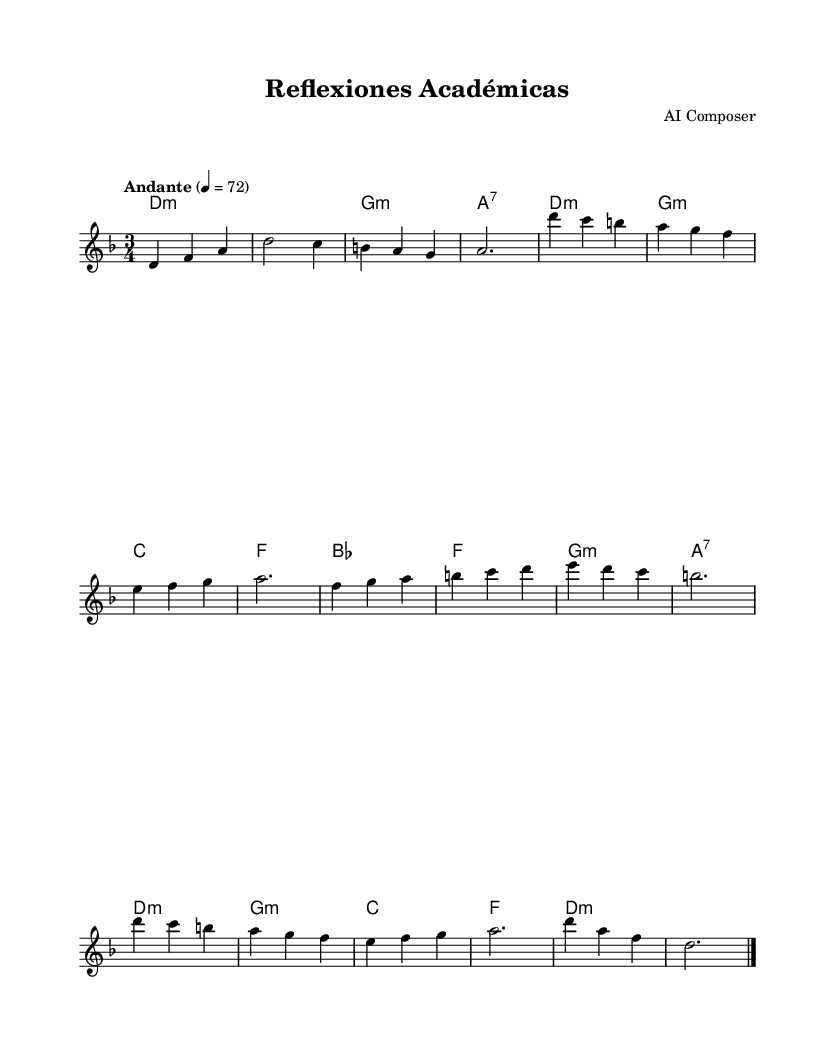What is the key signature of this music? The key signature is determined by the first section of the music, where there are no sharps or flats indicated. This means the key of D minor, which has one flat (B-flat), is set in this piece.
Answer: D minor What is the time signature of this music? The time signature is found at the beginning of the sheet music. In this case, it is indicated by the `3/4` at the start, which signifies that there are three beats in each measure.
Answer: 3/4 What is the tempo marking for this piece? The tempo marking is also noted at the beginning of the score, specifically indicated by the word "Andante" and the metronome marking of 72, which suggests a moderate pace.
Answer: Andante 4 = 72 What is the structure of the music? To determine the structure, we analyze the sections labeled as 'Intro', 'A', 'B', 'A'', and 'Coda'. This shows that the music follows a certain scheme, where 'A' sections are repeated.
Answer: Intro, A, B, A', Coda What is the dominant chord used in section A? In section A, the harmonies reveal that the chord progression starts in D minor and leads to G minor. The dominant chord (V) often resolves to the tonic; here, G minor serves as the dominant before returning to the tonic.
Answer: G minor What is the relationship between sections A and B in terms of tonality? By examining the harmonies, section A primarily oscillates between D minor and G minor, while section B introduces B-flat major as a new tonal center. This indicates a contrast between the two sections' tonalities.
Answer: Contrast How many measures are in the entire piece? The total number of measures can be identified by counting each line of the music. Each section has a specific number of measures, which must be totaled. The piece consists of 15 measures overall.
Answer: 15 